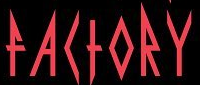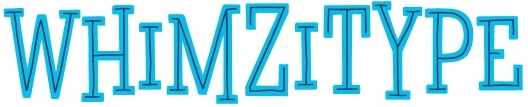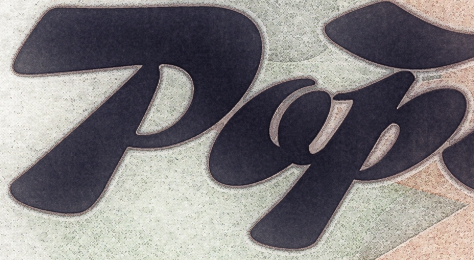Read the text content from these images in order, separated by a semicolon. FACTORY; WHIMZITYPE; Pop 